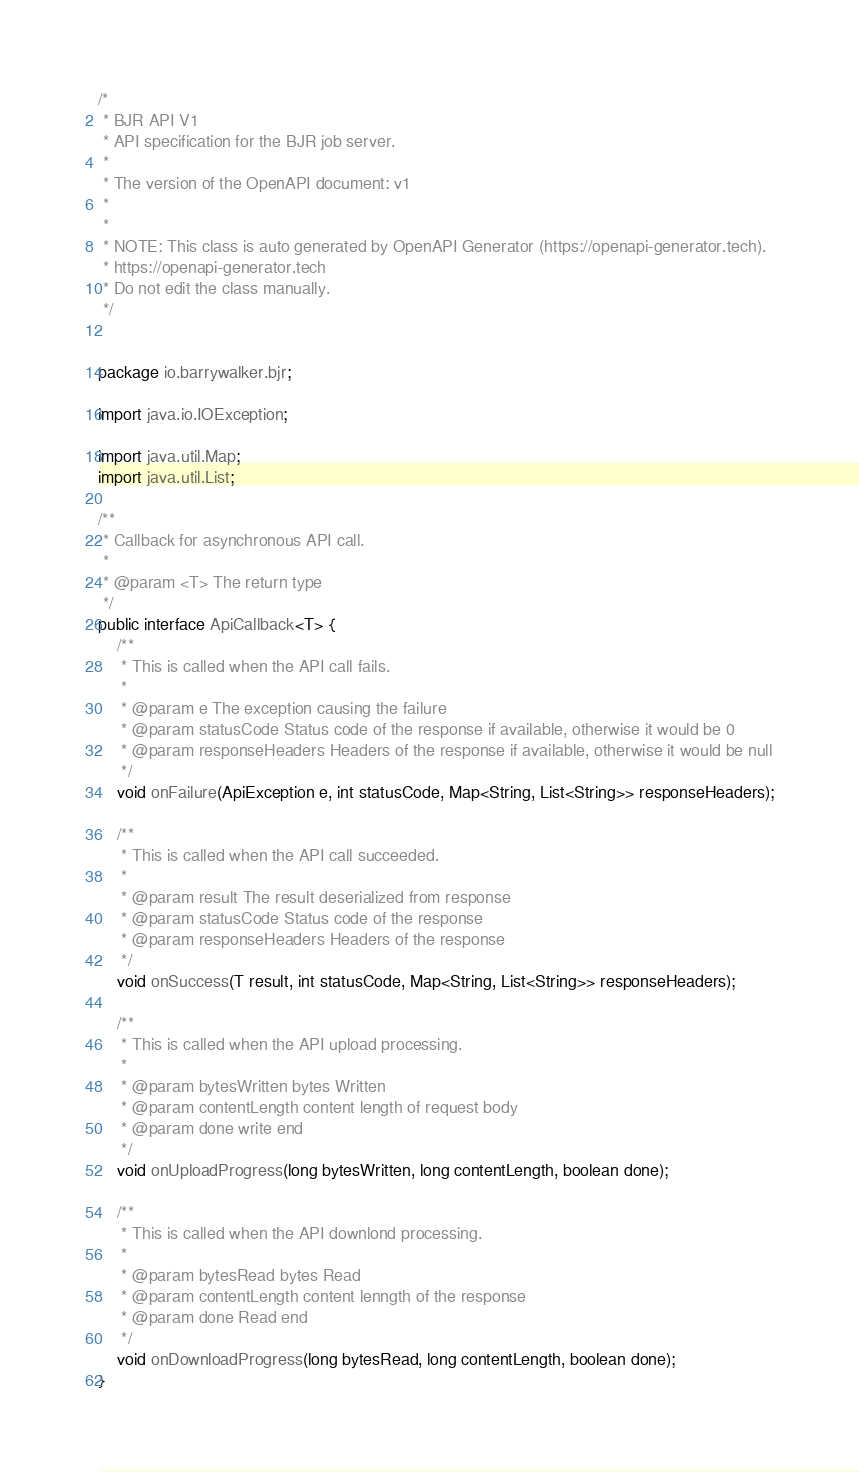<code> <loc_0><loc_0><loc_500><loc_500><_Java_>/*
 * BJR API V1
 * API specification for the BJR job server.
 *
 * The version of the OpenAPI document: v1
 * 
 *
 * NOTE: This class is auto generated by OpenAPI Generator (https://openapi-generator.tech).
 * https://openapi-generator.tech
 * Do not edit the class manually.
 */


package io.barrywalker.bjr;

import java.io.IOException;

import java.util.Map;
import java.util.List;

/**
 * Callback for asynchronous API call.
 *
 * @param <T> The return type
 */
public interface ApiCallback<T> {
    /**
     * This is called when the API call fails.
     *
     * @param e The exception causing the failure
     * @param statusCode Status code of the response if available, otherwise it would be 0
     * @param responseHeaders Headers of the response if available, otherwise it would be null
     */
    void onFailure(ApiException e, int statusCode, Map<String, List<String>> responseHeaders);

    /**
     * This is called when the API call succeeded.
     *
     * @param result The result deserialized from response
     * @param statusCode Status code of the response
     * @param responseHeaders Headers of the response
     */
    void onSuccess(T result, int statusCode, Map<String, List<String>> responseHeaders);

    /**
     * This is called when the API upload processing.
     *
     * @param bytesWritten bytes Written
     * @param contentLength content length of request body
     * @param done write end
     */
    void onUploadProgress(long bytesWritten, long contentLength, boolean done);

    /**
     * This is called when the API downlond processing.
     *
     * @param bytesRead bytes Read
     * @param contentLength content lenngth of the response
     * @param done Read end
     */
    void onDownloadProgress(long bytesRead, long contentLength, boolean done);
}
</code> 